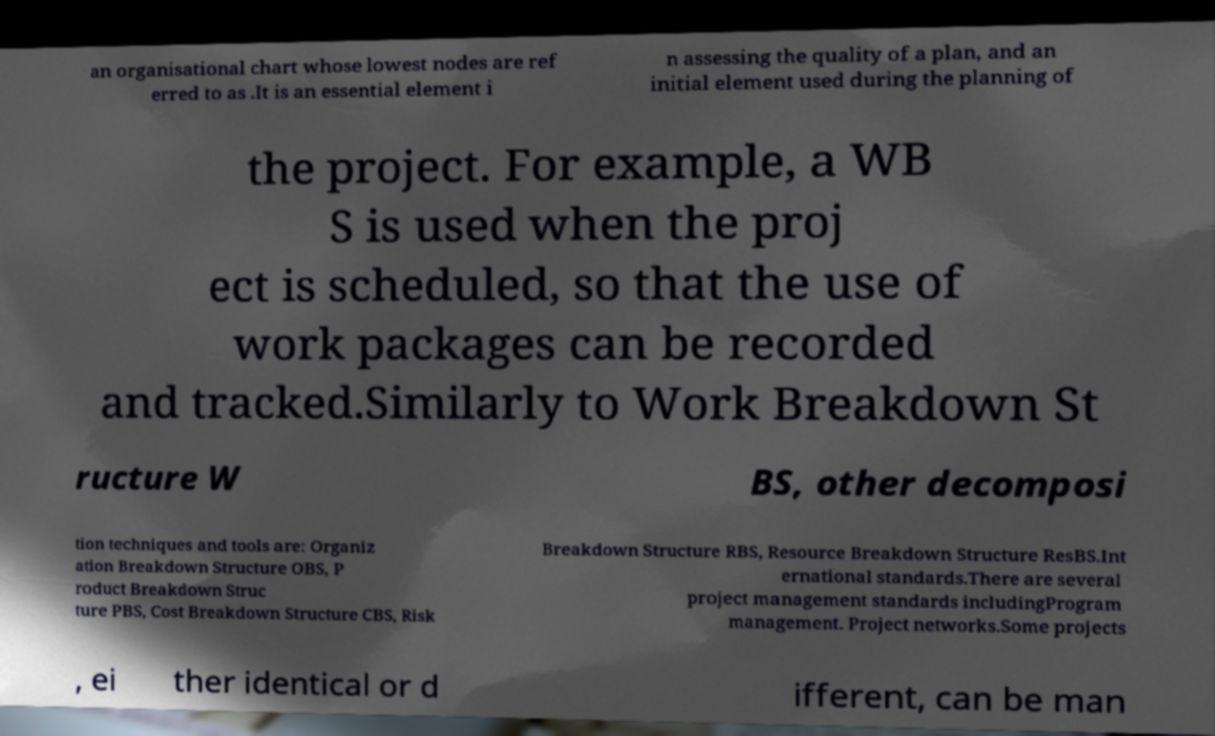Can you read and provide the text displayed in the image?This photo seems to have some interesting text. Can you extract and type it out for me? an organisational chart whose lowest nodes are ref erred to as .It is an essential element i n assessing the quality of a plan, and an initial element used during the planning of the project. For example, a WB S is used when the proj ect is scheduled, so that the use of work packages can be recorded and tracked.Similarly to Work Breakdown St ructure W BS, other decomposi tion techniques and tools are: Organiz ation Breakdown Structure OBS, P roduct Breakdown Struc ture PBS, Cost Breakdown Structure CBS, Risk Breakdown Structure RBS, Resource Breakdown Structure ResBS.Int ernational standards.There are several project management standards includingProgram management. Project networks.Some projects , ei ther identical or d ifferent, can be man 